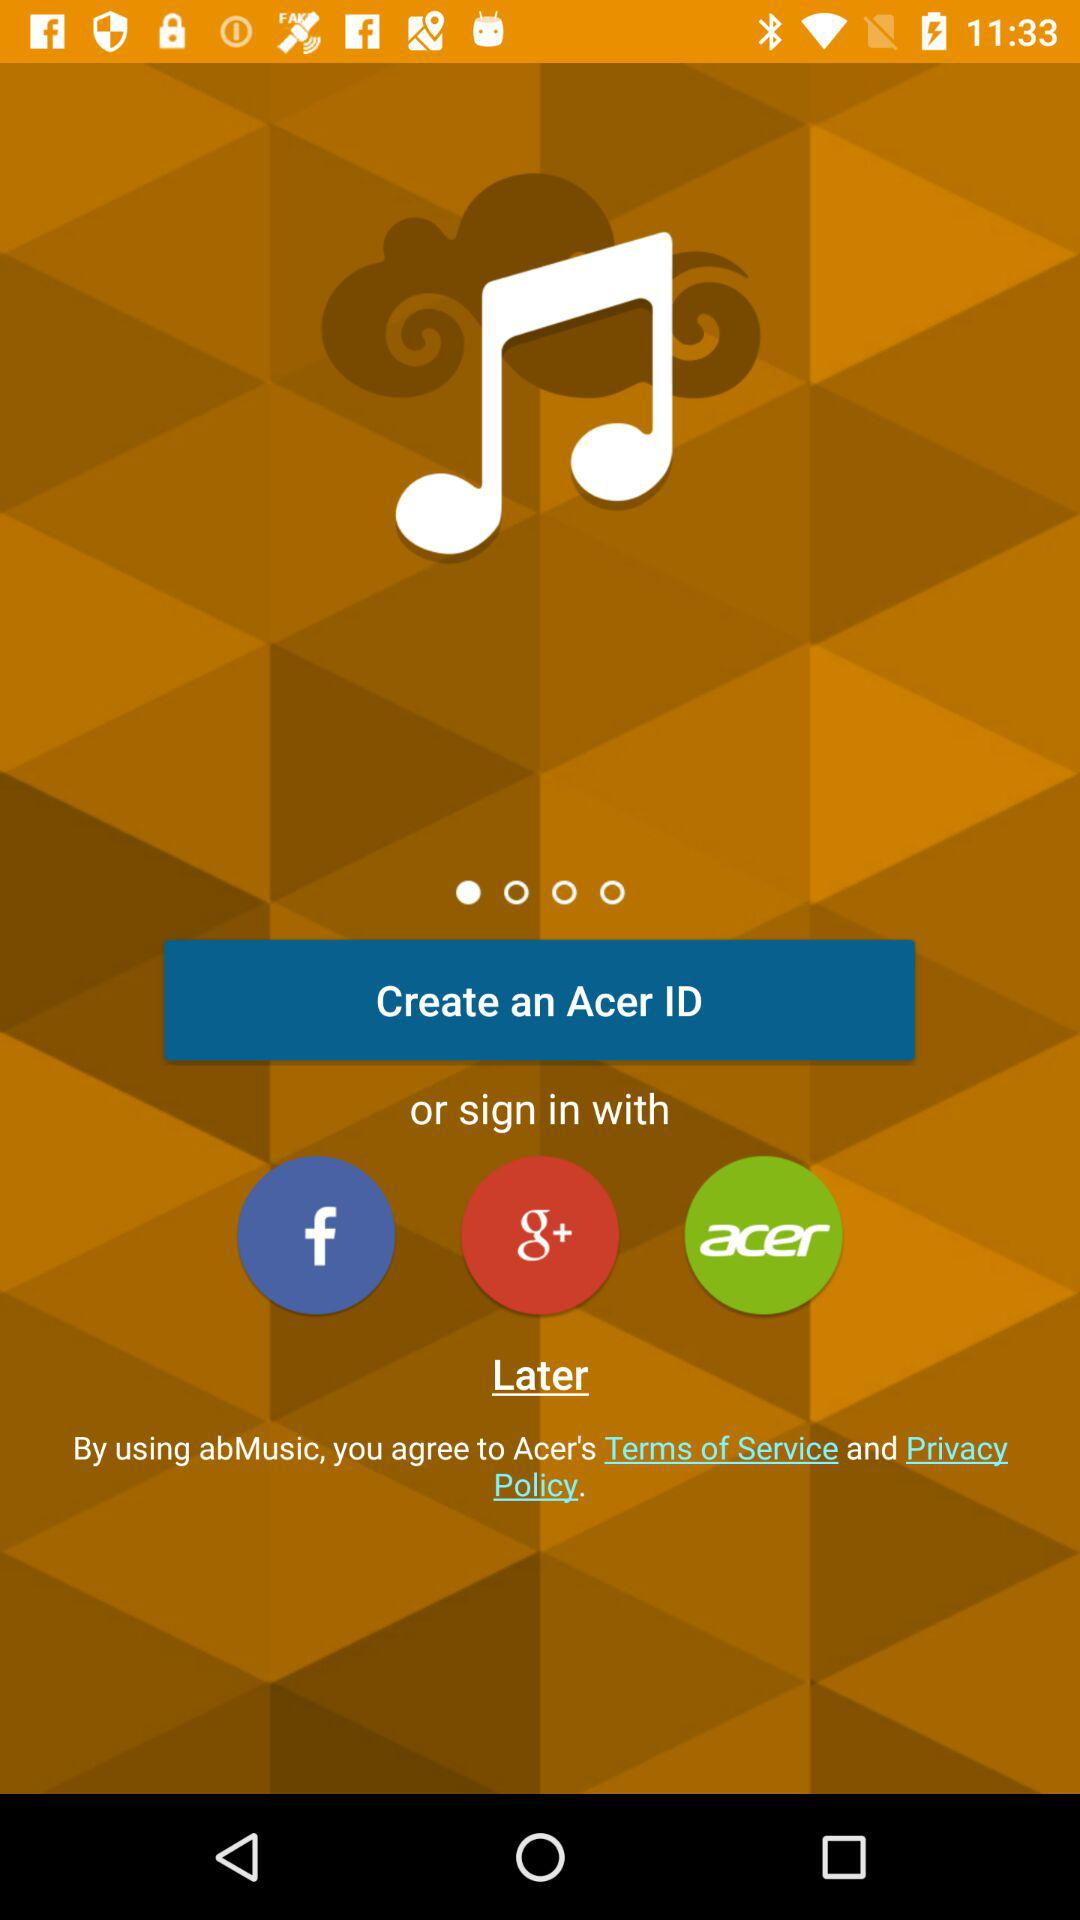What are the different options through which we can sign in? The different options through which we can sign in are "Facebook", "Google+" and "Acer". 